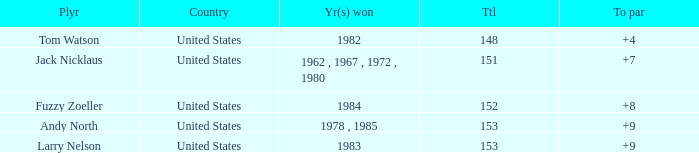What is the To par of Player Andy North with a Total larger than 153? 0.0. I'm looking to parse the entire table for insights. Could you assist me with that? {'header': ['Plyr', 'Country', 'Yr(s) won', 'Ttl', 'To par'], 'rows': [['Tom Watson', 'United States', '1982', '148', '+4'], ['Jack Nicklaus', 'United States', '1962 , 1967 , 1972 , 1980', '151', '+7'], ['Fuzzy Zoeller', 'United States', '1984', '152', '+8'], ['Andy North', 'United States', '1978 , 1985', '153', '+9'], ['Larry Nelson', 'United States', '1983', '153', '+9']]} 